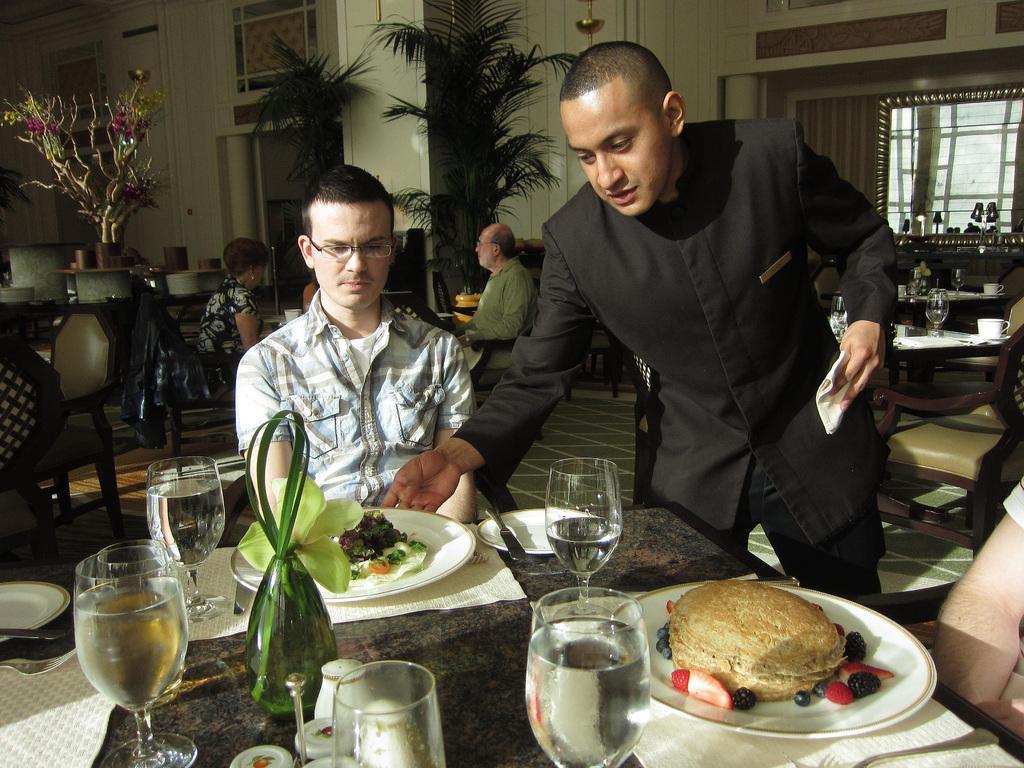Can you describe this image briefly? In the foreground of the image there is a table on which there are glasses, food items in plates and other objects. There is a person sitting on chair. Beside him there is a person standing wearing a black color dress. To the right side of the image there is a person sitting on chair. In the background of the image there are chairs , tables. There are people sitting on chairs. There is wall. There are plants. To the right side of the image there is a window. 